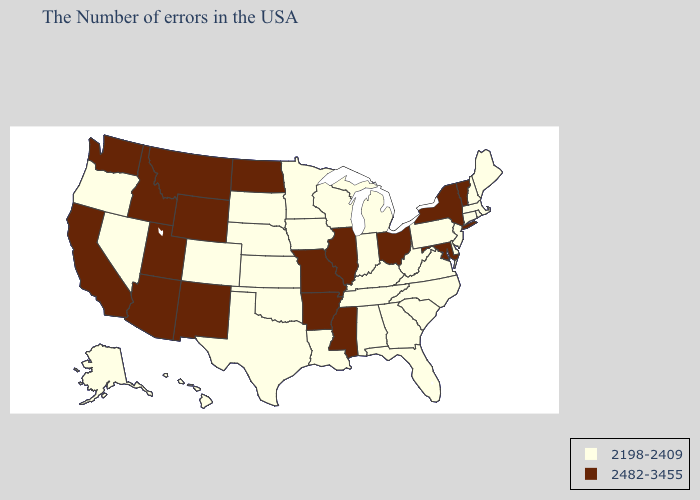Name the states that have a value in the range 2198-2409?
Keep it brief. Maine, Massachusetts, Rhode Island, New Hampshire, Connecticut, New Jersey, Delaware, Pennsylvania, Virginia, North Carolina, South Carolina, West Virginia, Florida, Georgia, Michigan, Kentucky, Indiana, Alabama, Tennessee, Wisconsin, Louisiana, Minnesota, Iowa, Kansas, Nebraska, Oklahoma, Texas, South Dakota, Colorado, Nevada, Oregon, Alaska, Hawaii. What is the lowest value in the West?
Keep it brief. 2198-2409. What is the lowest value in the MidWest?
Quick response, please. 2198-2409. What is the lowest value in the Northeast?
Keep it brief. 2198-2409. Name the states that have a value in the range 2198-2409?
Keep it brief. Maine, Massachusetts, Rhode Island, New Hampshire, Connecticut, New Jersey, Delaware, Pennsylvania, Virginia, North Carolina, South Carolina, West Virginia, Florida, Georgia, Michigan, Kentucky, Indiana, Alabama, Tennessee, Wisconsin, Louisiana, Minnesota, Iowa, Kansas, Nebraska, Oklahoma, Texas, South Dakota, Colorado, Nevada, Oregon, Alaska, Hawaii. Does the map have missing data?
Give a very brief answer. No. What is the value of Alabama?
Concise answer only. 2198-2409. Does Utah have the lowest value in the USA?
Write a very short answer. No. Name the states that have a value in the range 2482-3455?
Keep it brief. Vermont, New York, Maryland, Ohio, Illinois, Mississippi, Missouri, Arkansas, North Dakota, Wyoming, New Mexico, Utah, Montana, Arizona, Idaho, California, Washington. Which states have the lowest value in the South?
Write a very short answer. Delaware, Virginia, North Carolina, South Carolina, West Virginia, Florida, Georgia, Kentucky, Alabama, Tennessee, Louisiana, Oklahoma, Texas. Among the states that border Iowa , which have the lowest value?
Answer briefly. Wisconsin, Minnesota, Nebraska, South Dakota. What is the highest value in the West ?
Short answer required. 2482-3455. Does Kentucky have a higher value than New Jersey?
Quick response, please. No. What is the value of Vermont?
Write a very short answer. 2482-3455. 